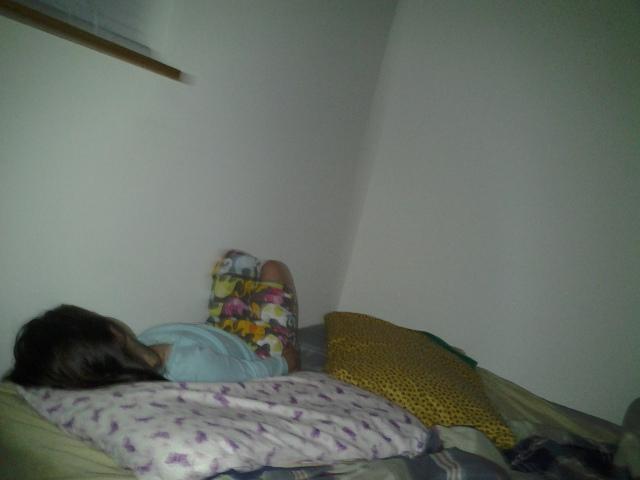How many pillows are there?
Give a very brief answer. 2. 